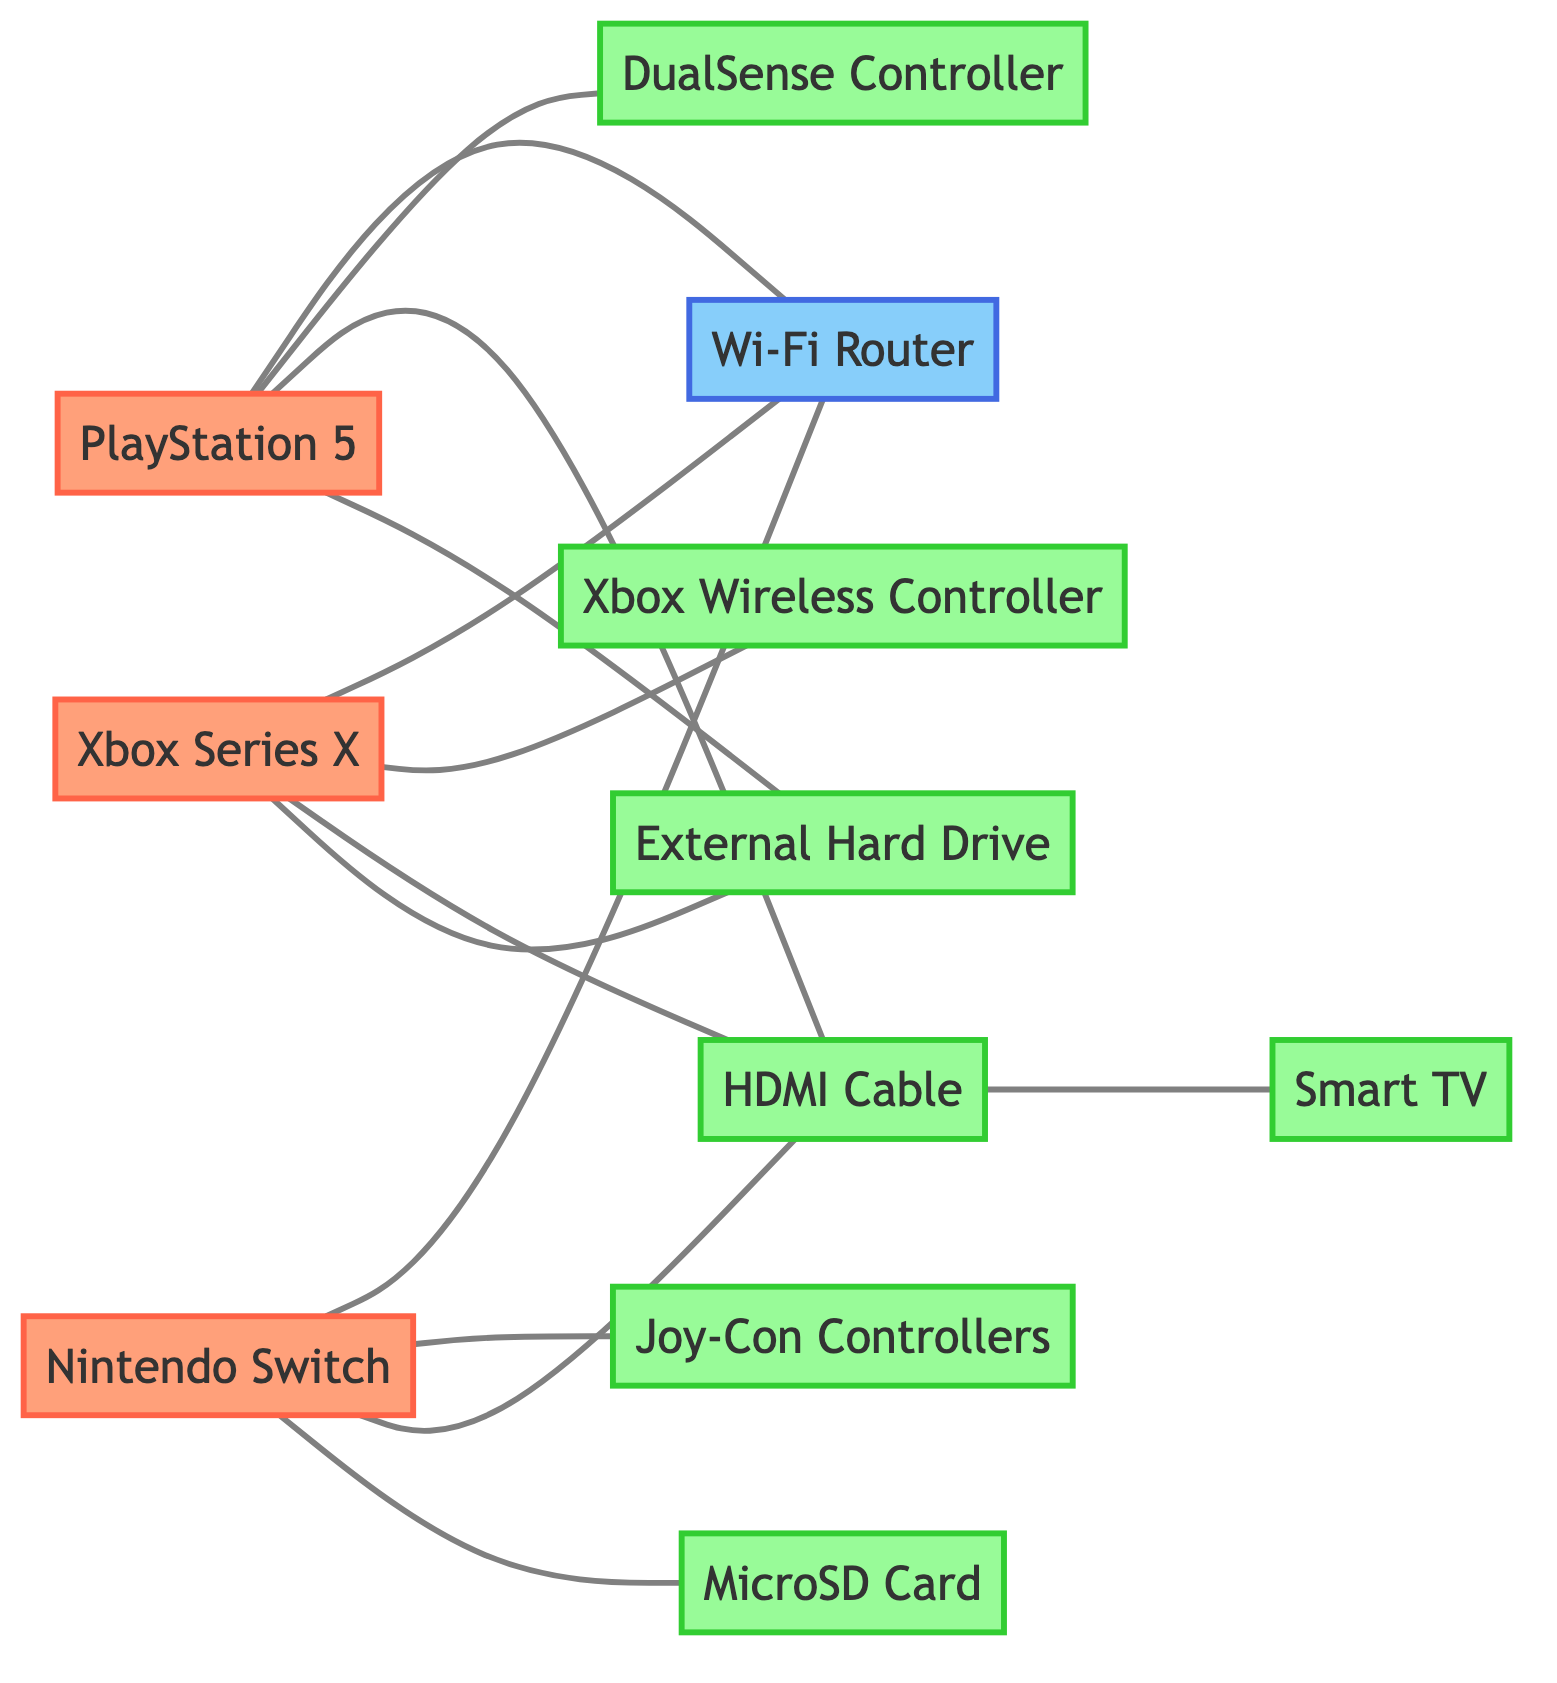What is the number of video game consoles in the diagram? The diagram features three video game consoles: PlayStation 5, Xbox Series X, and Nintendo Switch. Counting these nodes gives us a total of three.
Answer: 3 Which peripheral is connected to the PlayStation 5? Looking at the connections for the PlayStation 5 node, we see it is connected to the DualSense Controller, HDMI Cable, and External Hard Drive as peripherals. Therefore, any of these options is a valid answer.
Answer: DualSense Controller How many connections does the Wi-Fi Router have? The Wi-Fi Router is connected to three different consoles: PlayStation 5, Xbox Series X, and Nintendo Switch. This gives us a total of three connections from the Wi-Fi Router.
Answer: 3 What type of connection is used by the HDMI Cable? The HDMI Cable connects multiple devices in the diagram: PlayStation 5, Xbox Series X, Nintendo Switch, and Smart TV. Hence, the type of connection is peripheral.
Answer: Peripheral Which console does not have a MicroSD Card connected? From the connections listed, the PlayStation 5 and the Xbox Series X have no connection to a MicroSD Card, which is only connected to the Nintendo Switch. Hence, both PlayStation 5 and Xbox Series X do not connect to a MicroSD Card.
Answer: PlayStation 5 How many edges connect the external hard drive? The External Hard Drive has connections with two consoles: PlayStation 5 and Xbox Series X. Therefore, it is connected by two edges in the graph.
Answer: 2 Which console's controllers use wireless technology? The Xbox Series X has an Xbox Wireless Controller, which is explicitly mentioned as a wireless controller connected to the console.
Answer: Xbox Series X What is the total number of nodes in the diagram? To find the total nodes, we count all unique devices depicted: PlayStation 5, Xbox Series X, Nintendo Switch, Wi-Fi Router, DualSense Controller, Xbox Wireless Controller, Joy-Con Controllers, HDMI Cable, External Hard Drive, MicroSD Card, and Smart TV, yielding a total of 11 nodes.
Answer: 11 Which peripheral has the highest number of console connections? The HDMI Cable connects to three consoles: PlayStation 5, Xbox Series X, and Nintendo Switch. Hence, it holds the highest connection count among peripherals.
Answer: HDMI Cable 